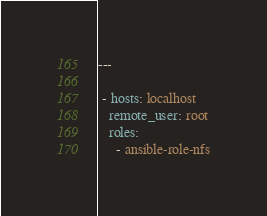<code> <loc_0><loc_0><loc_500><loc_500><_YAML_>---

 - hosts: localhost
   remote_user: root
   roles:
     - ansible-role-nfs
</code> 